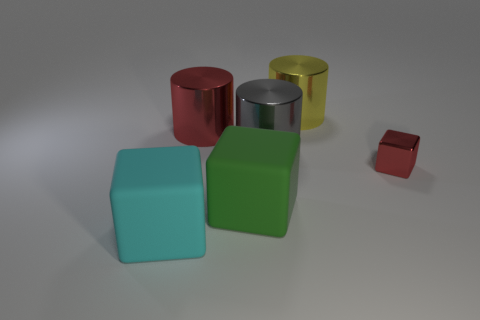Add 1 big red spheres. How many objects exist? 7 Subtract all yellow cylinders. How many cylinders are left? 2 Subtract all red cylinders. How many cylinders are left? 2 Subtract 2 blocks. How many blocks are left? 1 Subtract all blue cubes. Subtract all brown cylinders. How many cubes are left? 3 Subtract all green balls. How many blue cubes are left? 0 Subtract all big purple matte objects. Subtract all red cubes. How many objects are left? 5 Add 3 cyan things. How many cyan things are left? 4 Add 1 purple blocks. How many purple blocks exist? 1 Subtract 0 brown cylinders. How many objects are left? 6 